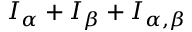Convert formula to latex. <formula><loc_0><loc_0><loc_500><loc_500>I _ { \alpha } + I _ { \beta } + I _ { \alpha , \beta }</formula> 